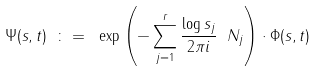<formula> <loc_0><loc_0><loc_500><loc_500>\Psi ( s , t ) \ \colon = \ \exp \left ( - \sum _ { j = 1 } ^ { r } \frac { \log s _ { j } } { 2 \pi i } \ N _ { j } \right ) \cdot \Phi ( s , t )</formula> 